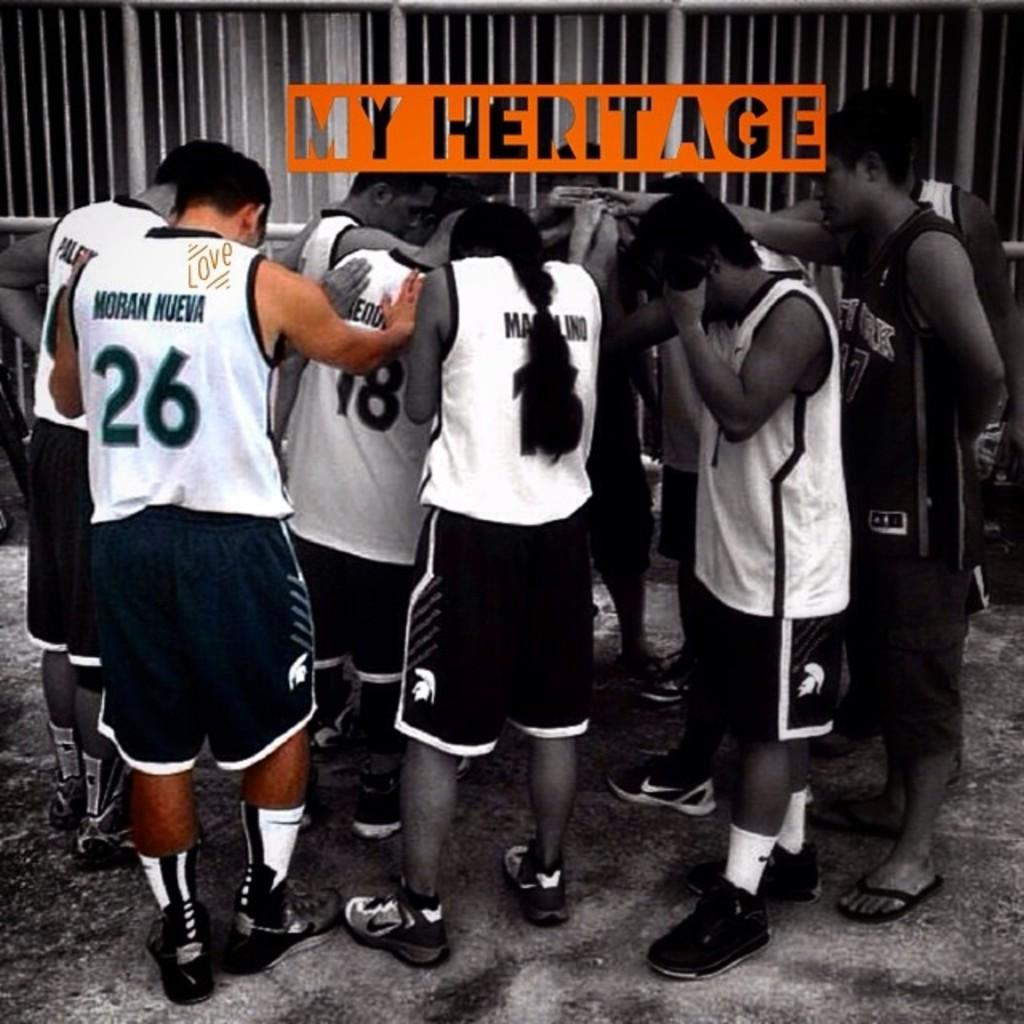<image>
Write a terse but informative summary of the picture. the picture labeled My Heritage showing a group of athletes standing in a circle 